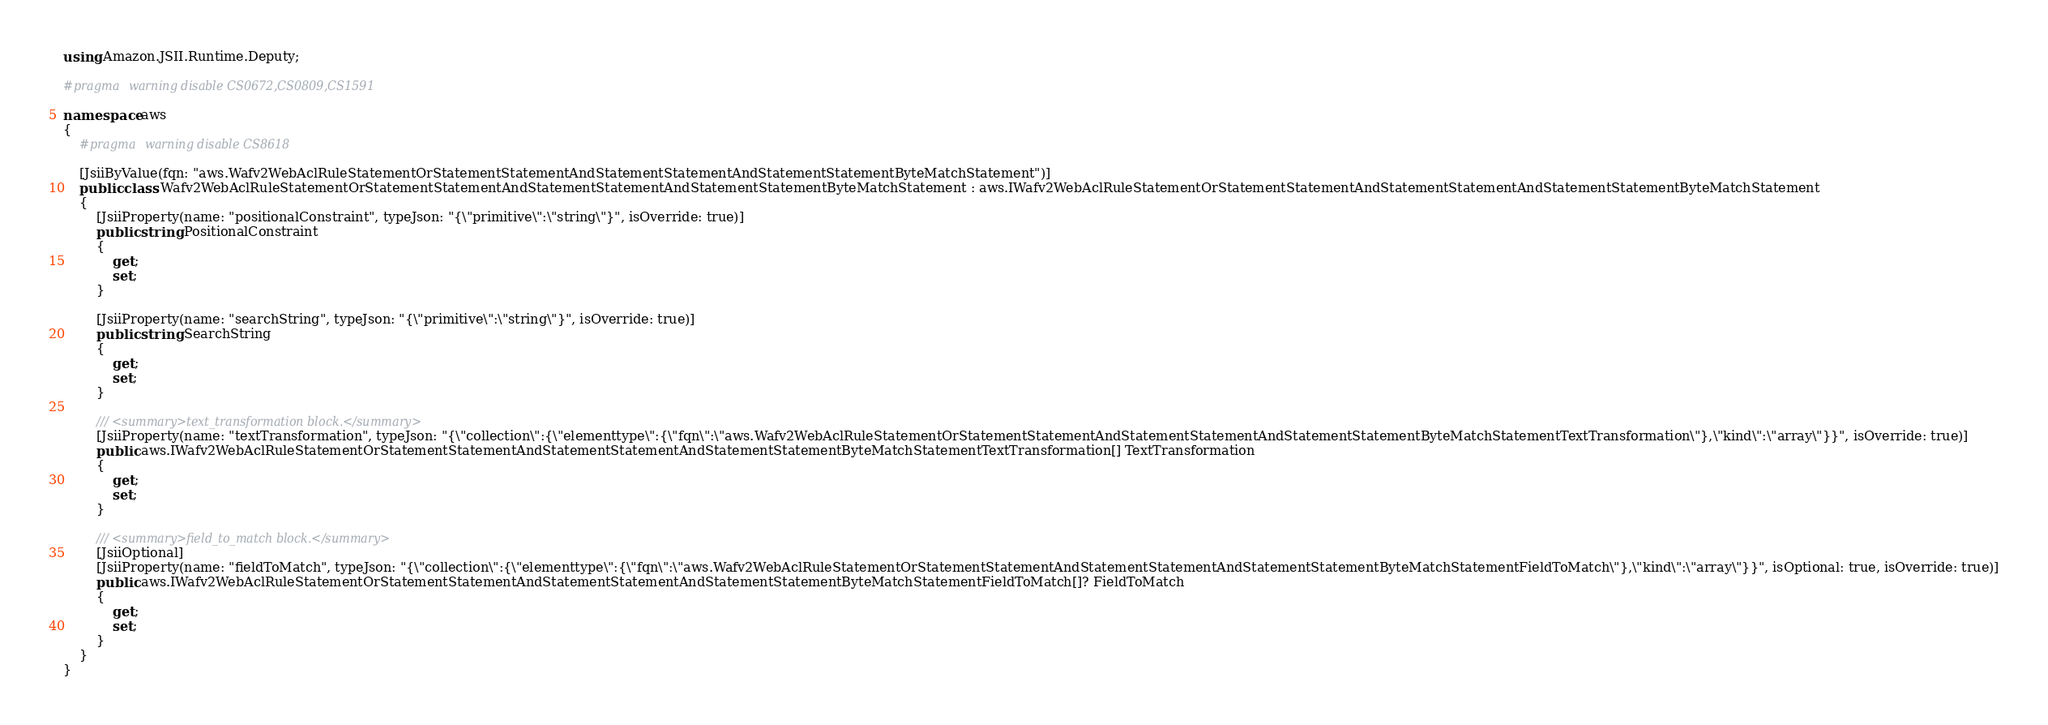Convert code to text. <code><loc_0><loc_0><loc_500><loc_500><_C#_>using Amazon.JSII.Runtime.Deputy;

#pragma warning disable CS0672,CS0809,CS1591

namespace aws
{
    #pragma warning disable CS8618

    [JsiiByValue(fqn: "aws.Wafv2WebAclRuleStatementOrStatementStatementAndStatementStatementAndStatementStatementByteMatchStatement")]
    public class Wafv2WebAclRuleStatementOrStatementStatementAndStatementStatementAndStatementStatementByteMatchStatement : aws.IWafv2WebAclRuleStatementOrStatementStatementAndStatementStatementAndStatementStatementByteMatchStatement
    {
        [JsiiProperty(name: "positionalConstraint", typeJson: "{\"primitive\":\"string\"}", isOverride: true)]
        public string PositionalConstraint
        {
            get;
            set;
        }

        [JsiiProperty(name: "searchString", typeJson: "{\"primitive\":\"string\"}", isOverride: true)]
        public string SearchString
        {
            get;
            set;
        }

        /// <summary>text_transformation block.</summary>
        [JsiiProperty(name: "textTransformation", typeJson: "{\"collection\":{\"elementtype\":{\"fqn\":\"aws.Wafv2WebAclRuleStatementOrStatementStatementAndStatementStatementAndStatementStatementByteMatchStatementTextTransformation\"},\"kind\":\"array\"}}", isOverride: true)]
        public aws.IWafv2WebAclRuleStatementOrStatementStatementAndStatementStatementAndStatementStatementByteMatchStatementTextTransformation[] TextTransformation
        {
            get;
            set;
        }

        /// <summary>field_to_match block.</summary>
        [JsiiOptional]
        [JsiiProperty(name: "fieldToMatch", typeJson: "{\"collection\":{\"elementtype\":{\"fqn\":\"aws.Wafv2WebAclRuleStatementOrStatementStatementAndStatementStatementAndStatementStatementByteMatchStatementFieldToMatch\"},\"kind\":\"array\"}}", isOptional: true, isOverride: true)]
        public aws.IWafv2WebAclRuleStatementOrStatementStatementAndStatementStatementAndStatementStatementByteMatchStatementFieldToMatch[]? FieldToMatch
        {
            get;
            set;
        }
    }
}
</code> 